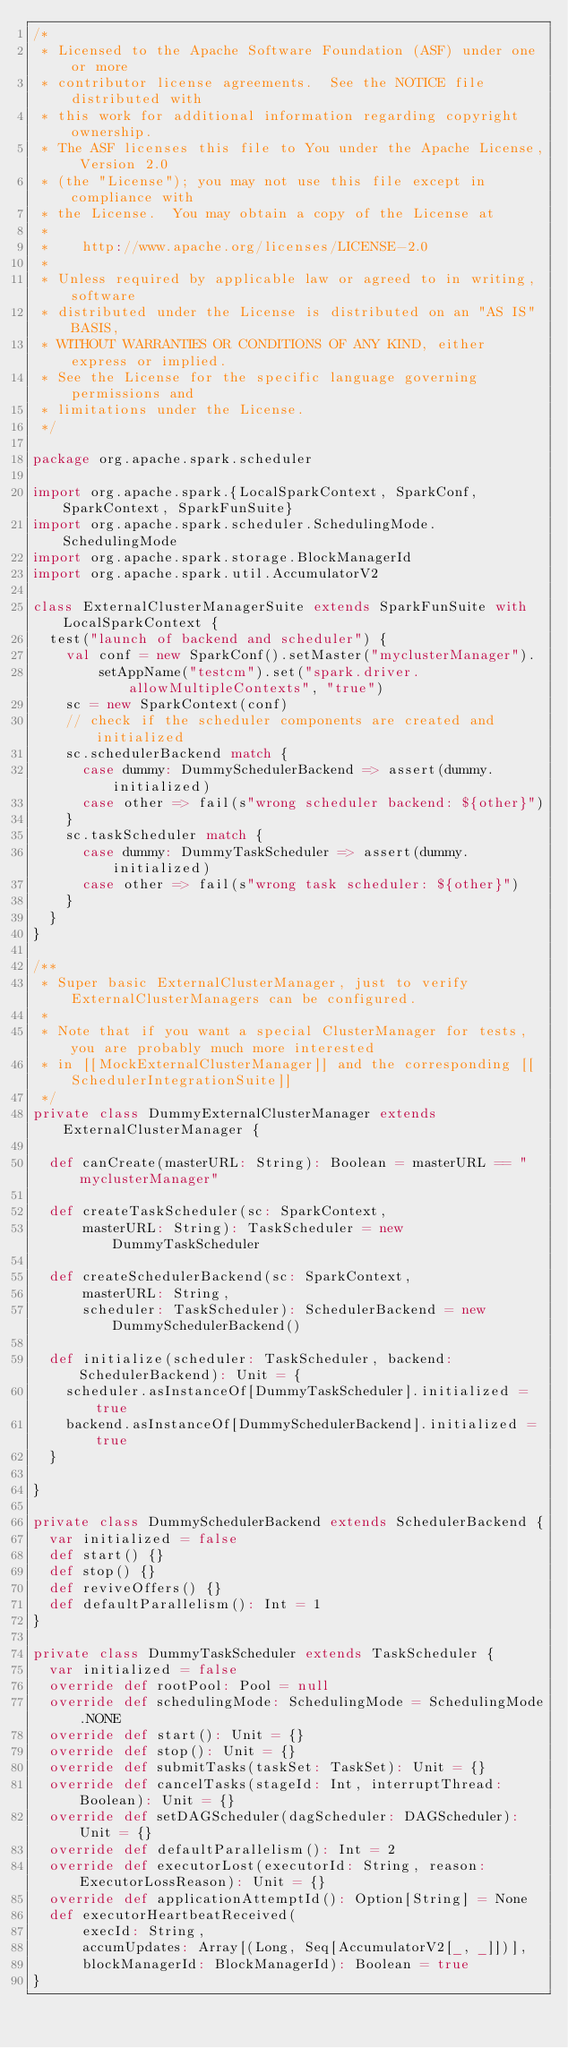Convert code to text. <code><loc_0><loc_0><loc_500><loc_500><_Scala_>/*
 * Licensed to the Apache Software Foundation (ASF) under one or more
 * contributor license agreements.  See the NOTICE file distributed with
 * this work for additional information regarding copyright ownership.
 * The ASF licenses this file to You under the Apache License, Version 2.0
 * (the "License"); you may not use this file except in compliance with
 * the License.  You may obtain a copy of the License at
 *
 *    http://www.apache.org/licenses/LICENSE-2.0
 *
 * Unless required by applicable law or agreed to in writing, software
 * distributed under the License is distributed on an "AS IS" BASIS,
 * WITHOUT WARRANTIES OR CONDITIONS OF ANY KIND, either express or implied.
 * See the License for the specific language governing permissions and
 * limitations under the License.
 */

package org.apache.spark.scheduler

import org.apache.spark.{LocalSparkContext, SparkConf, SparkContext, SparkFunSuite}
import org.apache.spark.scheduler.SchedulingMode.SchedulingMode
import org.apache.spark.storage.BlockManagerId
import org.apache.spark.util.AccumulatorV2

class ExternalClusterManagerSuite extends SparkFunSuite with LocalSparkContext {
  test("launch of backend and scheduler") {
    val conf = new SparkConf().setMaster("myclusterManager").
        setAppName("testcm").set("spark.driver.allowMultipleContexts", "true")
    sc = new SparkContext(conf)
    // check if the scheduler components are created and initialized
    sc.schedulerBackend match {
      case dummy: DummySchedulerBackend => assert(dummy.initialized)
      case other => fail(s"wrong scheduler backend: ${other}")
    }
    sc.taskScheduler match {
      case dummy: DummyTaskScheduler => assert(dummy.initialized)
      case other => fail(s"wrong task scheduler: ${other}")
    }
  }
}

/**
 * Super basic ExternalClusterManager, just to verify ExternalClusterManagers can be configured.
 *
 * Note that if you want a special ClusterManager for tests, you are probably much more interested
 * in [[MockExternalClusterManager]] and the corresponding [[SchedulerIntegrationSuite]]
 */
private class DummyExternalClusterManager extends ExternalClusterManager {

  def canCreate(masterURL: String): Boolean = masterURL == "myclusterManager"

  def createTaskScheduler(sc: SparkContext,
      masterURL: String): TaskScheduler = new DummyTaskScheduler

  def createSchedulerBackend(sc: SparkContext,
      masterURL: String,
      scheduler: TaskScheduler): SchedulerBackend = new DummySchedulerBackend()

  def initialize(scheduler: TaskScheduler, backend: SchedulerBackend): Unit = {
    scheduler.asInstanceOf[DummyTaskScheduler].initialized = true
    backend.asInstanceOf[DummySchedulerBackend].initialized = true
  }

}

private class DummySchedulerBackend extends SchedulerBackend {
  var initialized = false
  def start() {}
  def stop() {}
  def reviveOffers() {}
  def defaultParallelism(): Int = 1
}

private class DummyTaskScheduler extends TaskScheduler {
  var initialized = false
  override def rootPool: Pool = null
  override def schedulingMode: SchedulingMode = SchedulingMode.NONE
  override def start(): Unit = {}
  override def stop(): Unit = {}
  override def submitTasks(taskSet: TaskSet): Unit = {}
  override def cancelTasks(stageId: Int, interruptThread: Boolean): Unit = {}
  override def setDAGScheduler(dagScheduler: DAGScheduler): Unit = {}
  override def defaultParallelism(): Int = 2
  override def executorLost(executorId: String, reason: ExecutorLossReason): Unit = {}
  override def applicationAttemptId(): Option[String] = None
  def executorHeartbeatReceived(
      execId: String,
      accumUpdates: Array[(Long, Seq[AccumulatorV2[_, _]])],
      blockManagerId: BlockManagerId): Boolean = true
}
</code> 